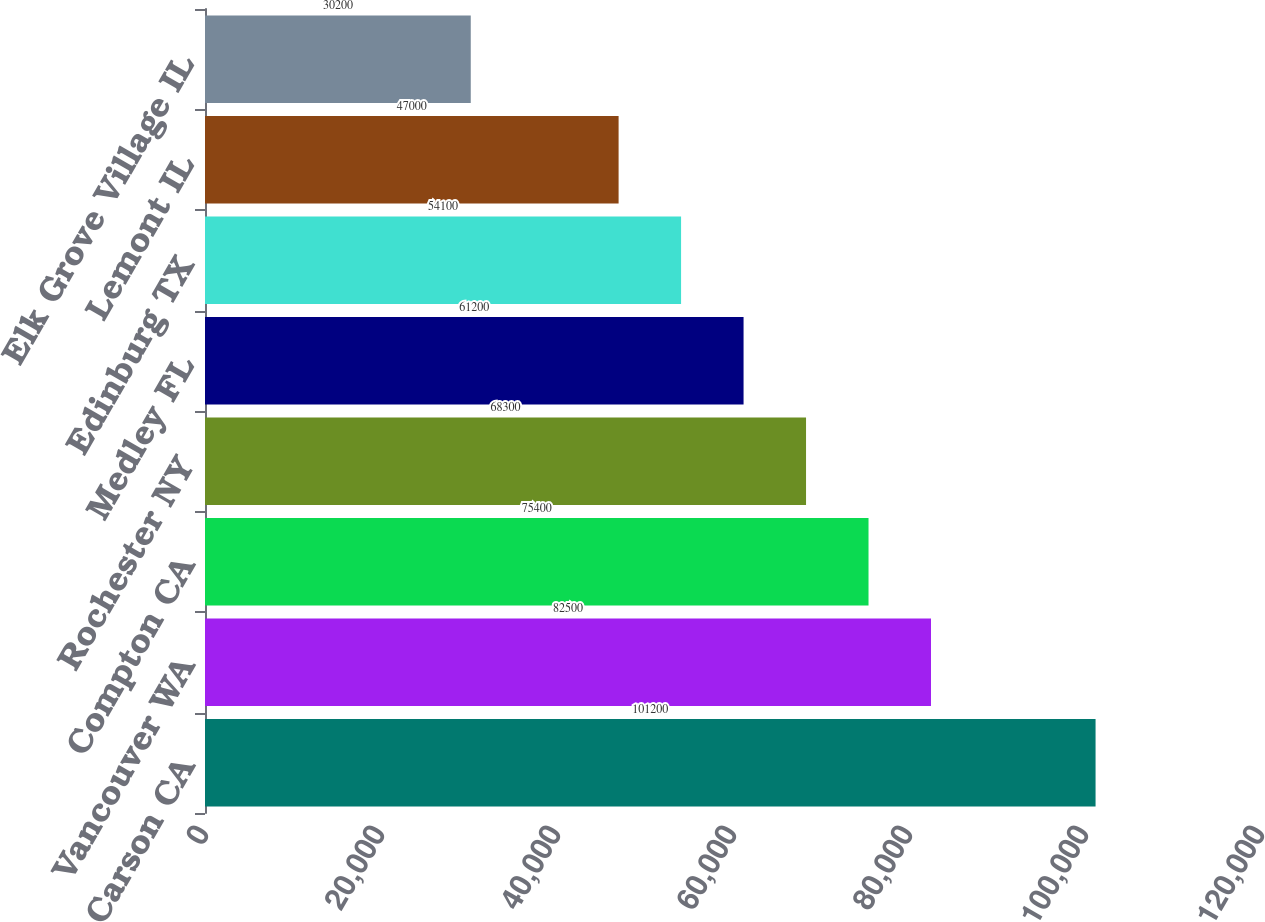Convert chart. <chart><loc_0><loc_0><loc_500><loc_500><bar_chart><fcel>Carson CA<fcel>Vancouver WA<fcel>Compton CA<fcel>Rochester NY<fcel>Medley FL<fcel>Edinburg TX<fcel>Lemont IL<fcel>Elk Grove Village IL<nl><fcel>101200<fcel>82500<fcel>75400<fcel>68300<fcel>61200<fcel>54100<fcel>47000<fcel>30200<nl></chart> 